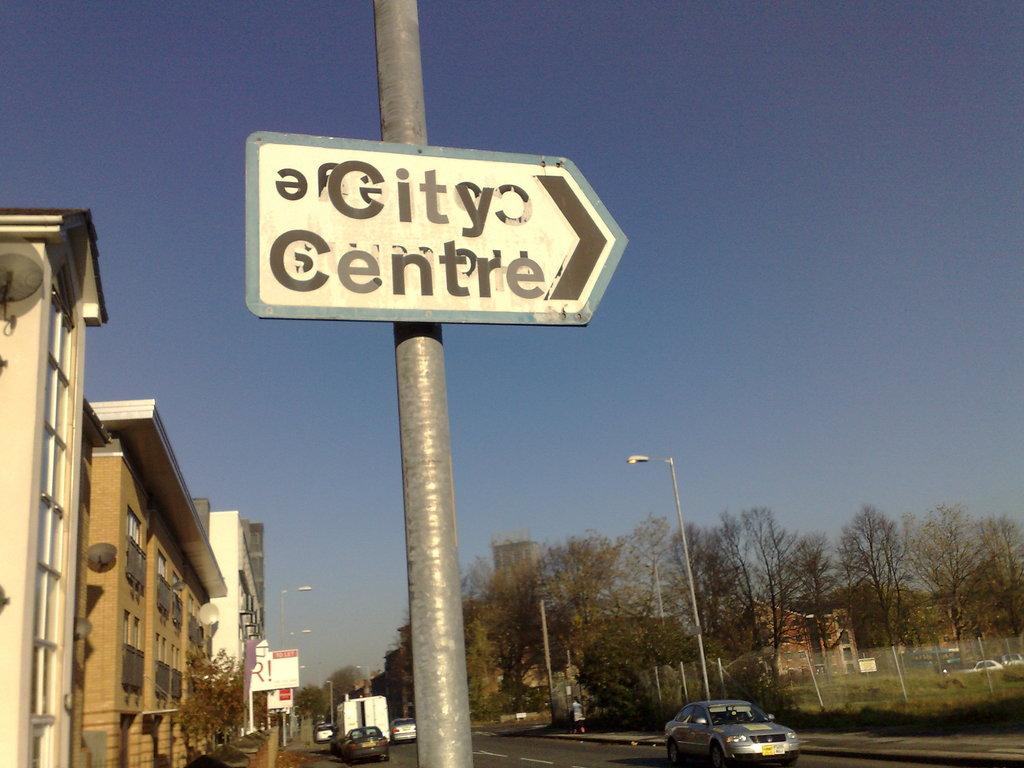What is located in the foreground of the image? There is a sign board in the foreground of the image. How is the sign board attached? The sign board is attached to a pole. What can be seen in the background of the image? There are buildings, poles, trees, vehicles moving on the road, fencing, and the sky visible in the background of the image. Can you see a kitty playing with a heart on the seashore in the image? No, there is no kitty, heart, or seashore present in the image. 